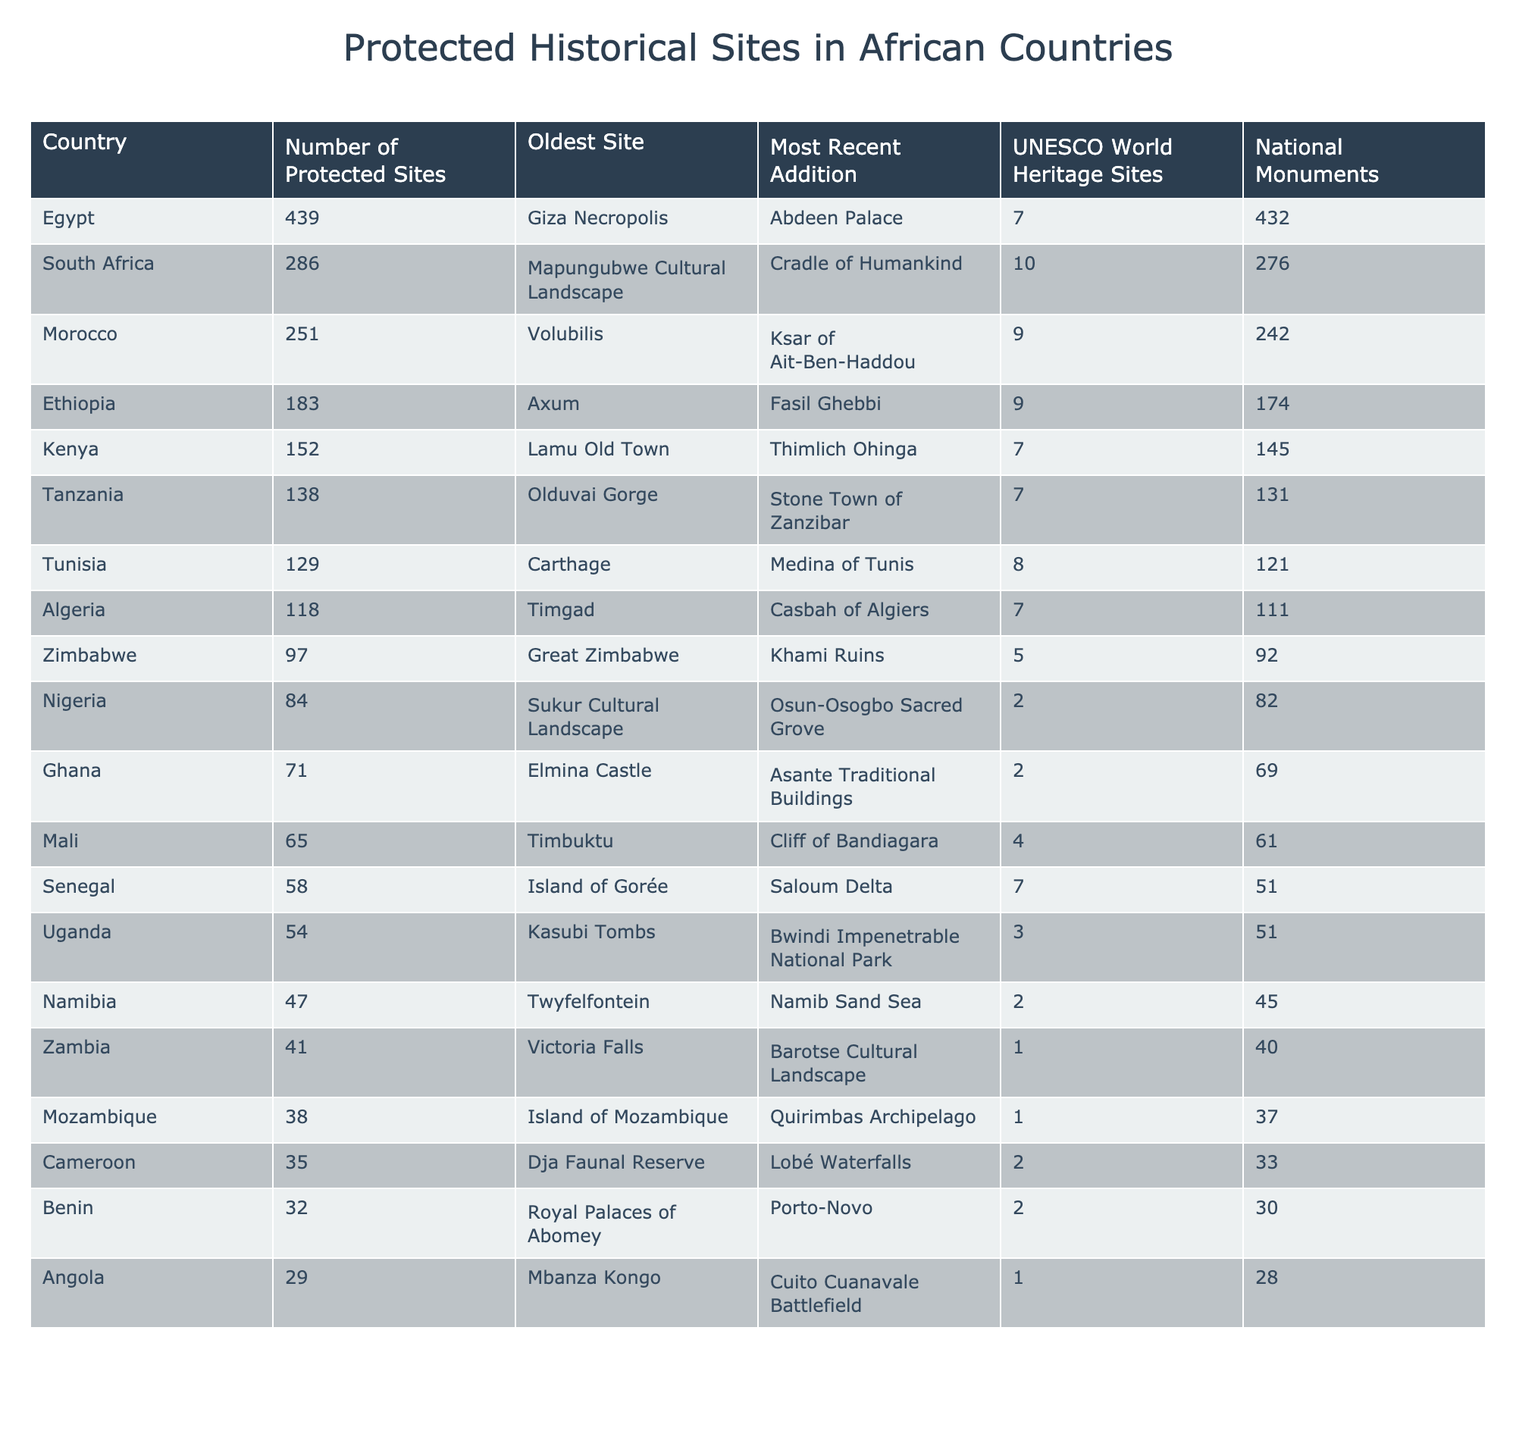What country has the most protected historical sites? Egypt has the highest number of protected historical sites, totaling 439, which is the largest figure in the table.
Answer: Egypt How many UNESCO World Heritage Sites does South Africa have? South Africa has 10 UNESCO World Heritage Sites, as indicated in the specific column for UNESCO sites in the table.
Answer: 10 Which country has the oldest protected site, and what is it? Egypt has the oldest protected site, which is the Giza Necropolis, as shown in the 'Oldest Site' column.
Answer: Egypt, Giza Necropolis What is the total number of national monuments in Ethiopia and Kenya combined? Ethiopia has 174 national monuments and Kenya has 145; summing these gives 174 + 145 = 319.
Answer: 319 Is Nigeria listed as having more or fewer national monuments than Ghana? Nigeria has 82 national monuments while Ghana has 69, therefore Nigeria has more national monuments than Ghana.
Answer: More What is the difference in the number of protected sites between Egypt and Morocco? Egypt has 439 protected sites and Morocco has 251; calculating the difference gives 439 - 251 = 188.
Answer: 188 Which country has the most recent addition of a protected site, and what is that site? South Africa has the most recent addition, which is the Cradle of Humankind, noted in the 'Most Recent Addition' column.
Answer: South Africa, Cradle of Humankind Calculate the average number of protected sites across the top three countries. The top three countries are Egypt (439), South Africa (286), and Morocco (251). Summing these gives 439 + 286 + 251 = 976, and dividing by 3 gives an average of 976/3 ≈ 325.33.
Answer: Approximately 325.33 How many national monuments does Algeria have compared to Namibia? Algeria has 111 national monuments while Namibia has 45. Since 111 is greater than 45, Algeria has more national monuments than Namibia.
Answer: Algeria has more Which country has the lowest number of protected sites and how many are there? Mozambique has the lowest number of protected sites with a total of 38, as indicated in the table.
Answer: Mozambique, 38 